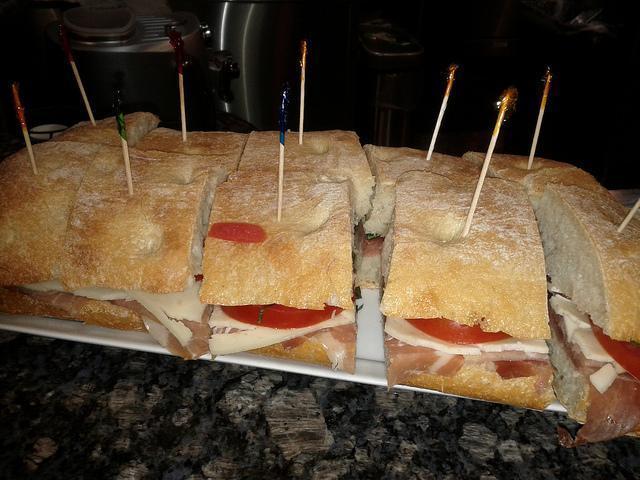How many people could eat this?
Give a very brief answer. 10. How many sandwich pieces are there?
Give a very brief answer. 10. How many sandwiches can be seen?
Give a very brief answer. 10. 